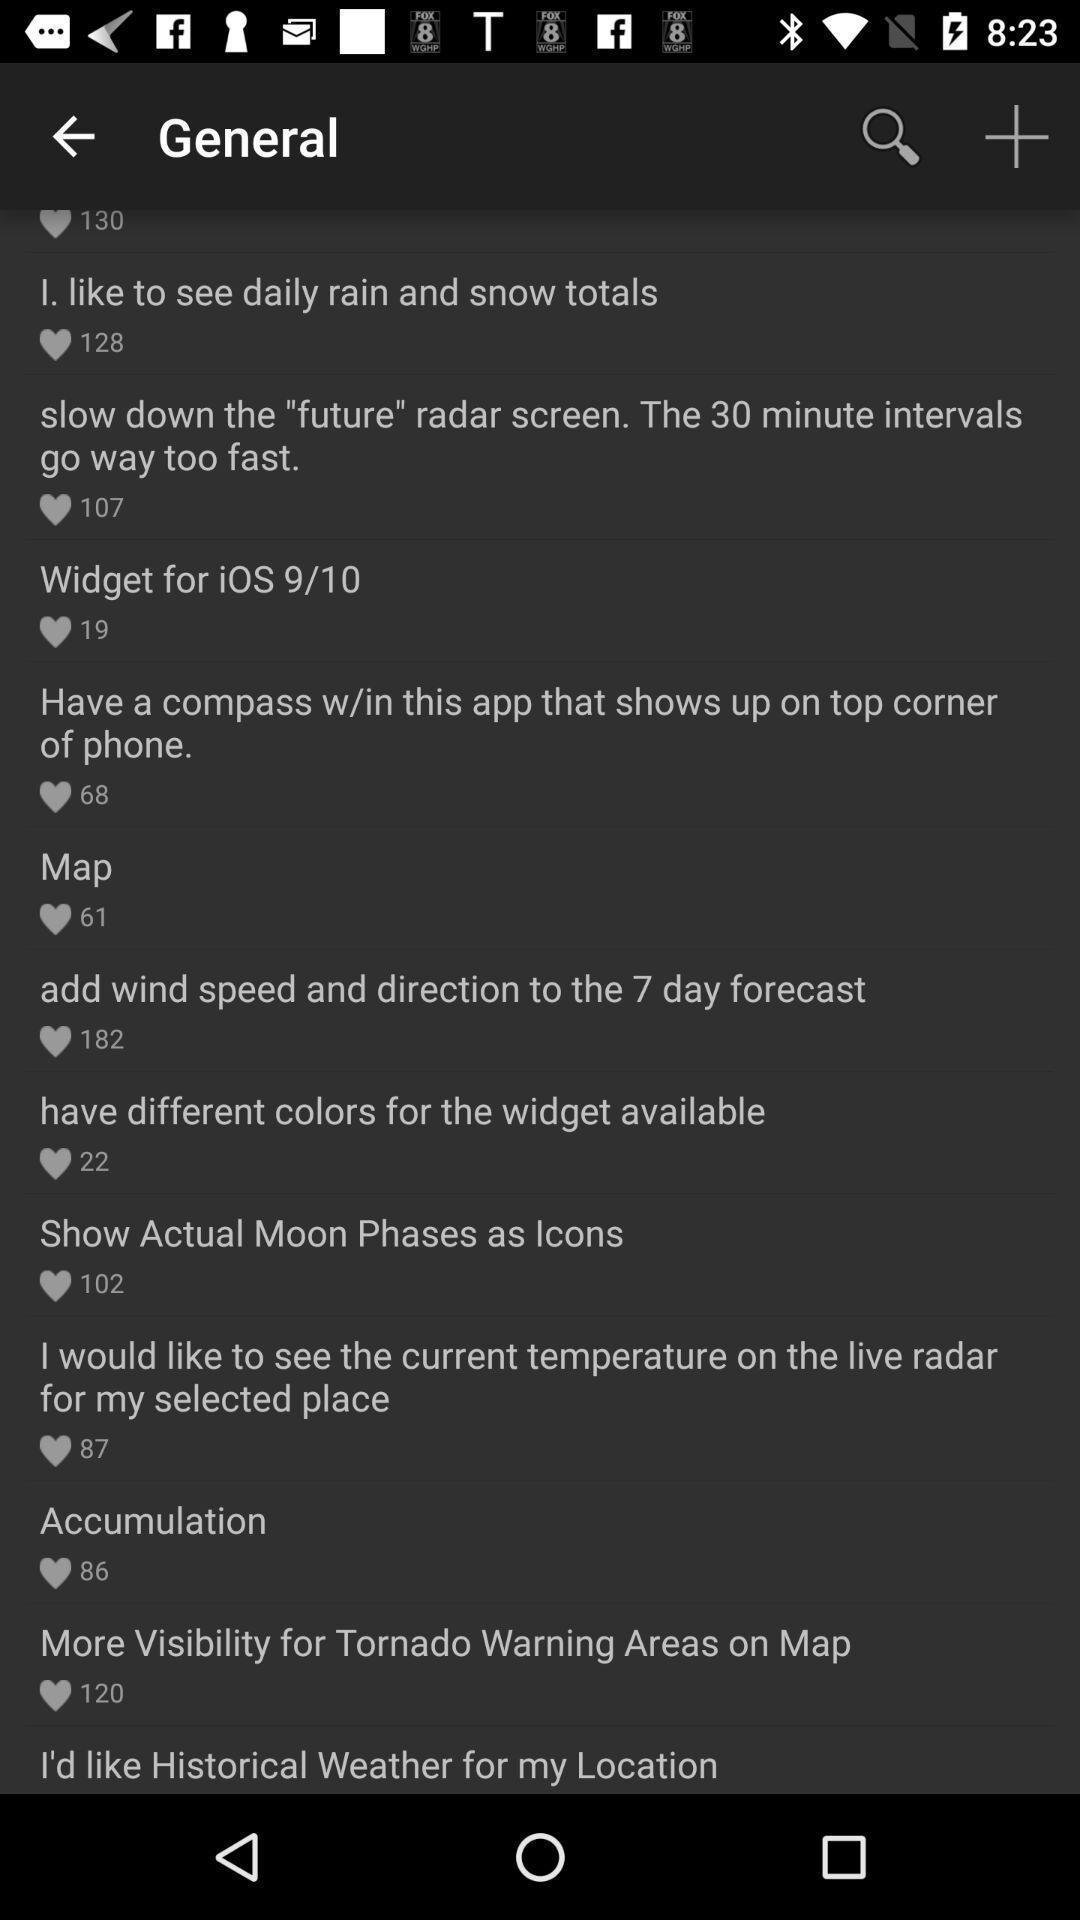Explain what's happening in this screen capture. Page showing general post 's with likes. 